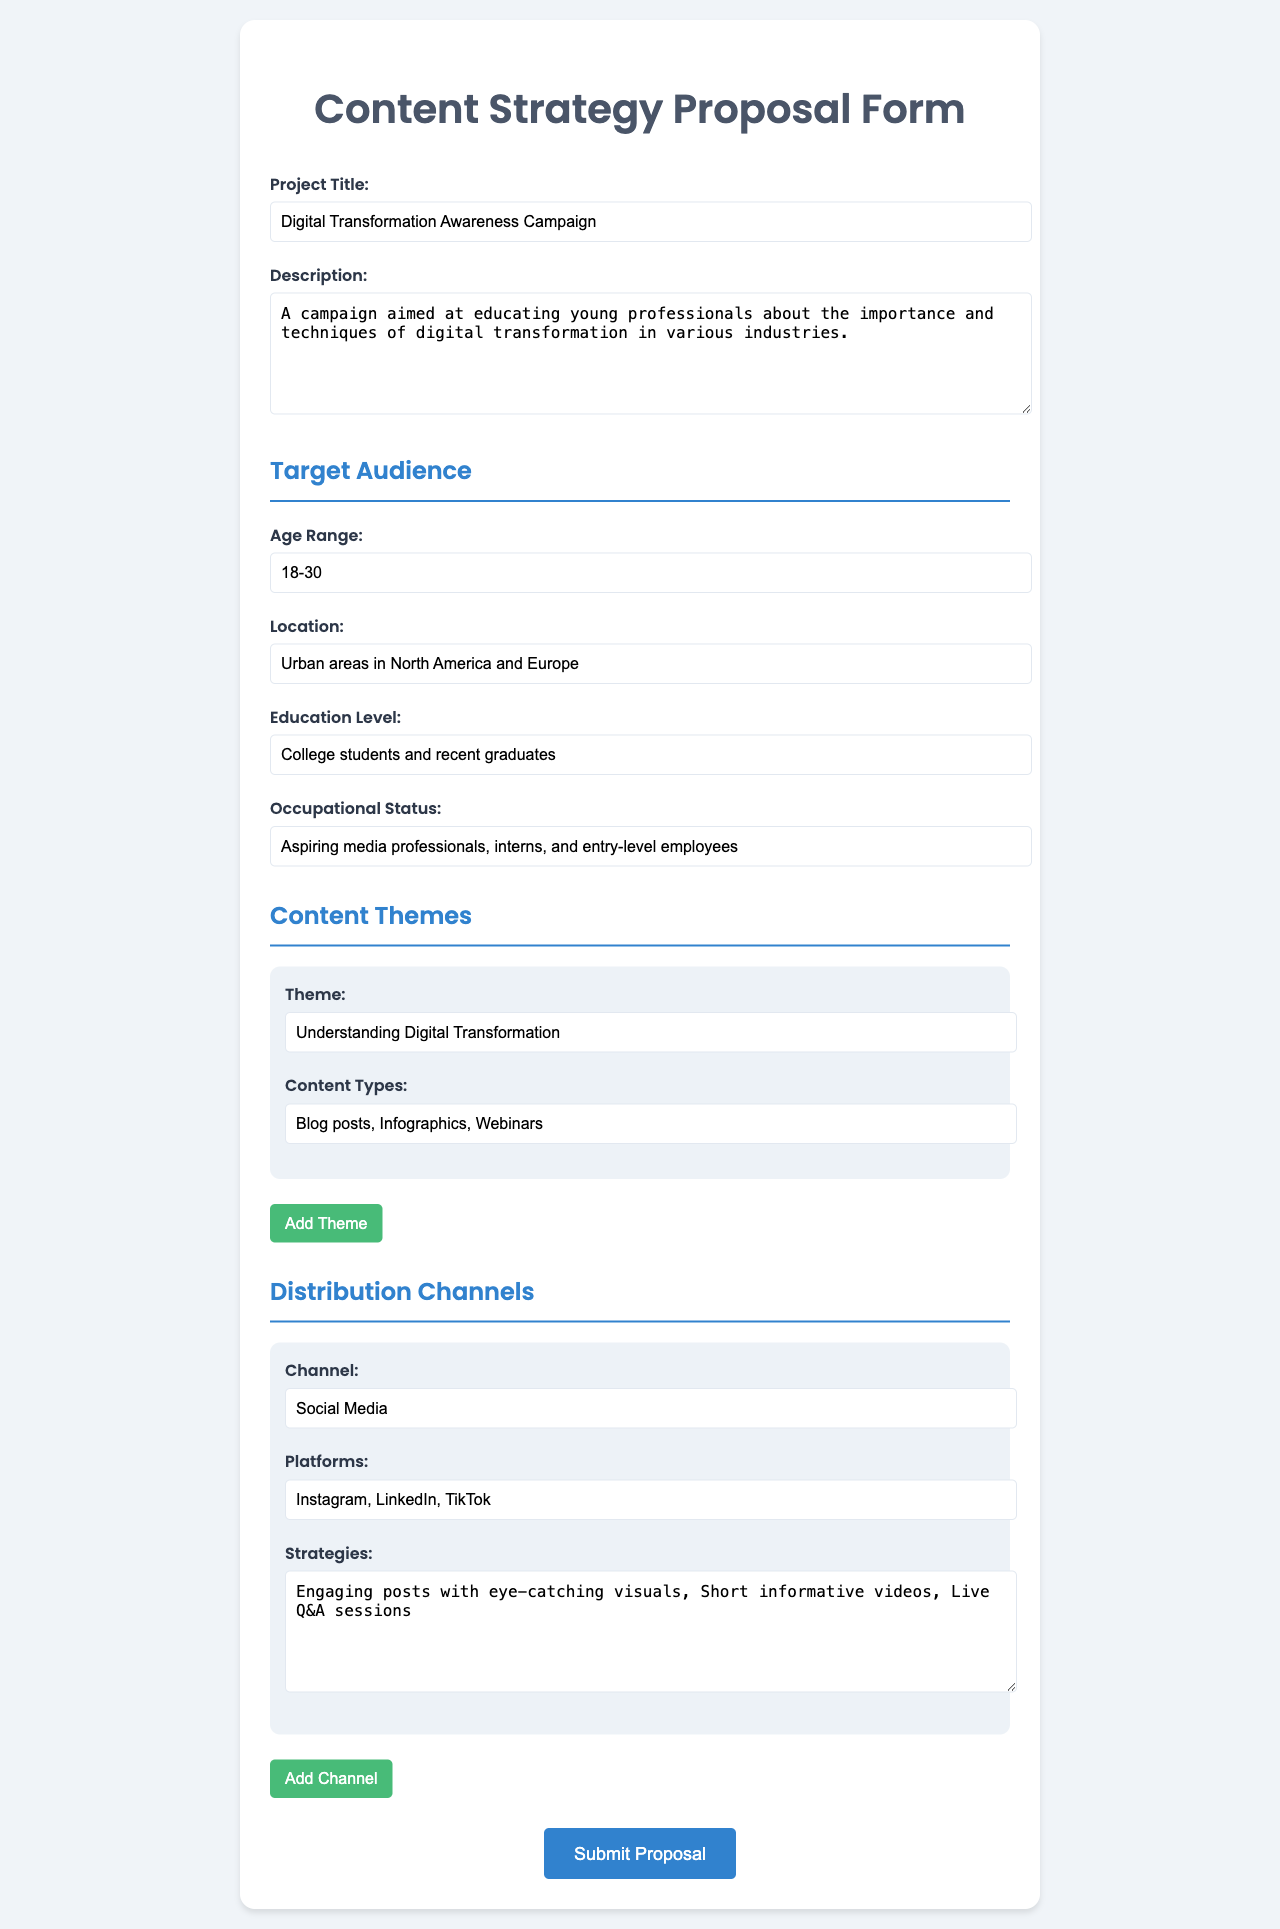What is the project title? The project title is stated in the document as "Digital Transformation Awareness Campaign."
Answer: Digital Transformation Awareness Campaign What is the age range of the target audience? The age range of the target audience is specifically mentioned in the document as 18-30.
Answer: 18-30 Which location is focused on for the target audience? The document specifies the location as "Urban areas in North America and Europe."
Answer: Urban areas in North America and Europe What is the first content theme listed in the document? The first content theme is indicated in the document as "Understanding Digital Transformation."
Answer: Understanding Digital Transformation What are the platforms mentioned for distribution? The platforms listed for distribution channels include "Instagram, LinkedIn, TikTok."
Answer: Instagram, LinkedIn, TikTok What is the educational level of the target audience? The educational level is specified in the document as "College students and recent graduates."
Answer: College students and recent graduates What is the occupational status defined for the target audience? The occupational status mentioned in the document is "Aspiring media professionals, interns, and entry-level employees."
Answer: Aspiring media professionals, interns, and entry-level employees What types of content are included in the first theme? The document states that the types of content for the first theme are "Blog posts, Infographics, Webinars."
Answer: Blog posts, Infographics, Webinars What is the first distribution channel listed in the document? The first distribution channel mentioned is "Social Media."
Answer: Social Media 